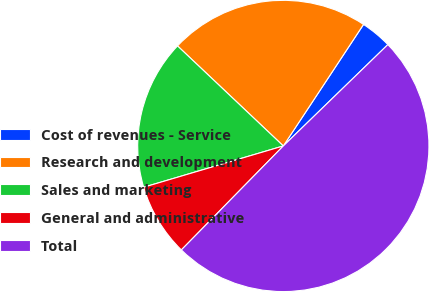<chart> <loc_0><loc_0><loc_500><loc_500><pie_chart><fcel>Cost of revenues - Service<fcel>Research and development<fcel>Sales and marketing<fcel>General and administrative<fcel>Total<nl><fcel>3.46%<fcel>22.23%<fcel>16.63%<fcel>8.08%<fcel>49.6%<nl></chart> 